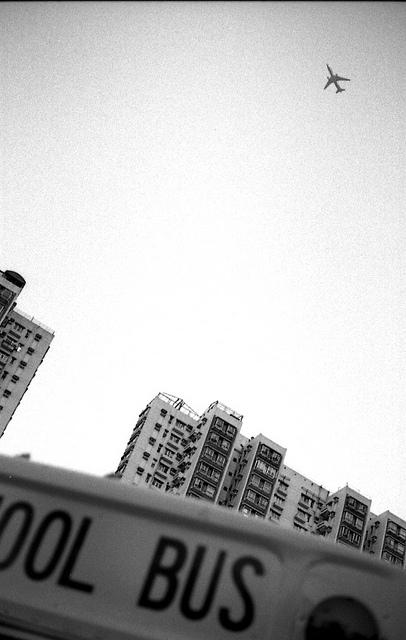How many aircraft are in the sky?
Concise answer only. 1. What does the sky look like?
Short answer required. Clear. What word is on the front?
Write a very short answer. Bus. 